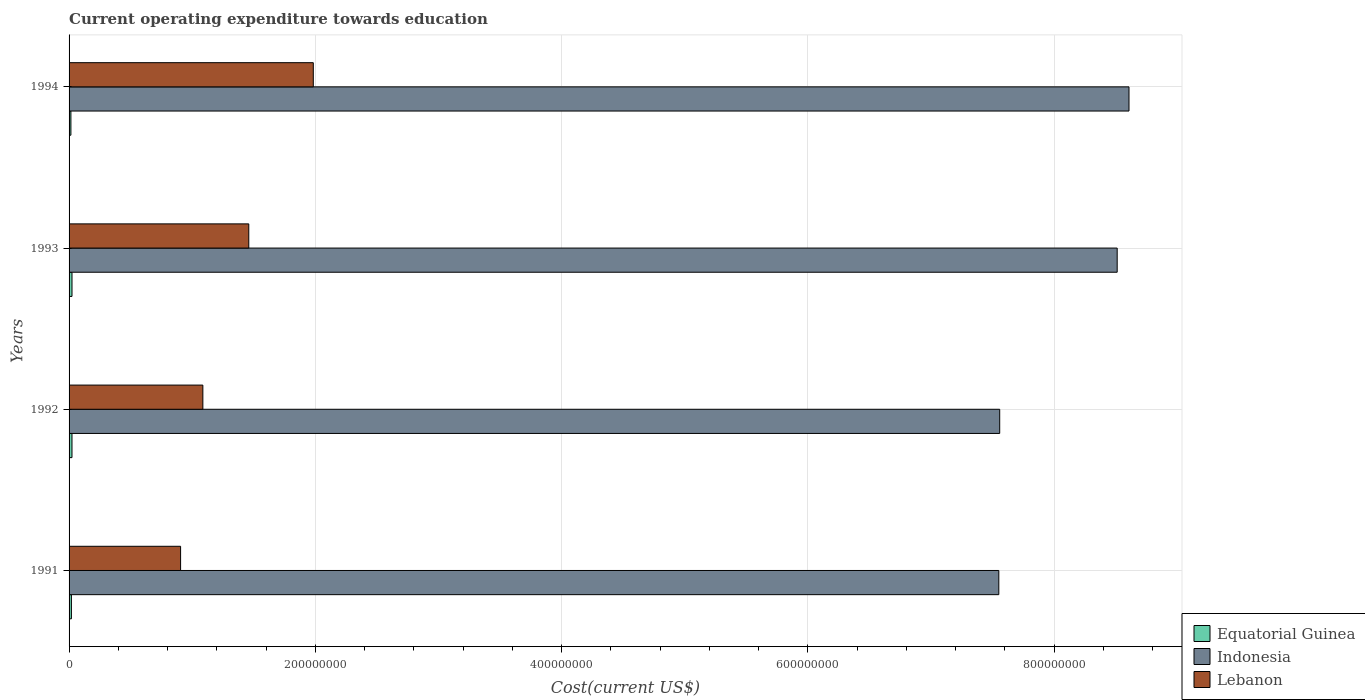How many different coloured bars are there?
Give a very brief answer. 3. How many groups of bars are there?
Keep it short and to the point. 4. Are the number of bars on each tick of the Y-axis equal?
Your answer should be very brief. Yes. How many bars are there on the 3rd tick from the top?
Make the answer very short. 3. What is the label of the 2nd group of bars from the top?
Ensure brevity in your answer.  1993. What is the expenditure towards education in Indonesia in 1992?
Your response must be concise. 7.56e+08. Across all years, what is the maximum expenditure towards education in Lebanon?
Keep it short and to the point. 1.98e+08. Across all years, what is the minimum expenditure towards education in Equatorial Guinea?
Provide a succinct answer. 1.50e+06. What is the total expenditure towards education in Indonesia in the graph?
Ensure brevity in your answer.  3.22e+09. What is the difference between the expenditure towards education in Equatorial Guinea in 1992 and that in 1993?
Your answer should be compact. -1.02e+04. What is the difference between the expenditure towards education in Equatorial Guinea in 1992 and the expenditure towards education in Indonesia in 1994?
Provide a succinct answer. -8.58e+08. What is the average expenditure towards education in Equatorial Guinea per year?
Provide a short and direct response. 2.03e+06. In the year 1992, what is the difference between the expenditure towards education in Indonesia and expenditure towards education in Lebanon?
Give a very brief answer. 6.47e+08. What is the ratio of the expenditure towards education in Indonesia in 1993 to that in 1994?
Provide a short and direct response. 0.99. Is the expenditure towards education in Indonesia in 1992 less than that in 1994?
Ensure brevity in your answer.  Yes. Is the difference between the expenditure towards education in Indonesia in 1992 and 1994 greater than the difference between the expenditure towards education in Lebanon in 1992 and 1994?
Your answer should be compact. No. What is the difference between the highest and the second highest expenditure towards education in Equatorial Guinea?
Offer a very short reply. 1.02e+04. What is the difference between the highest and the lowest expenditure towards education in Indonesia?
Your response must be concise. 1.06e+08. What does the 1st bar from the top in 1992 represents?
Keep it short and to the point. Lebanon. What does the 3rd bar from the bottom in 1993 represents?
Provide a succinct answer. Lebanon. Does the graph contain any zero values?
Your answer should be compact. No. Does the graph contain grids?
Your answer should be compact. Yes. Where does the legend appear in the graph?
Keep it short and to the point. Bottom right. What is the title of the graph?
Your answer should be compact. Current operating expenditure towards education. Does "Congo (Republic)" appear as one of the legend labels in the graph?
Provide a succinct answer. No. What is the label or title of the X-axis?
Offer a very short reply. Cost(current US$). What is the label or title of the Y-axis?
Ensure brevity in your answer.  Years. What is the Cost(current US$) of Equatorial Guinea in 1991?
Provide a short and direct response. 1.89e+06. What is the Cost(current US$) of Indonesia in 1991?
Ensure brevity in your answer.  7.55e+08. What is the Cost(current US$) in Lebanon in 1991?
Ensure brevity in your answer.  9.06e+07. What is the Cost(current US$) of Equatorial Guinea in 1992?
Give a very brief answer. 2.37e+06. What is the Cost(current US$) in Indonesia in 1992?
Ensure brevity in your answer.  7.56e+08. What is the Cost(current US$) in Lebanon in 1992?
Provide a short and direct response. 1.09e+08. What is the Cost(current US$) in Equatorial Guinea in 1993?
Provide a short and direct response. 2.38e+06. What is the Cost(current US$) in Indonesia in 1993?
Your response must be concise. 8.51e+08. What is the Cost(current US$) in Lebanon in 1993?
Make the answer very short. 1.46e+08. What is the Cost(current US$) of Equatorial Guinea in 1994?
Keep it short and to the point. 1.50e+06. What is the Cost(current US$) of Indonesia in 1994?
Offer a terse response. 8.61e+08. What is the Cost(current US$) in Lebanon in 1994?
Keep it short and to the point. 1.98e+08. Across all years, what is the maximum Cost(current US$) in Equatorial Guinea?
Your response must be concise. 2.38e+06. Across all years, what is the maximum Cost(current US$) of Indonesia?
Your answer should be very brief. 8.61e+08. Across all years, what is the maximum Cost(current US$) of Lebanon?
Your answer should be very brief. 1.98e+08. Across all years, what is the minimum Cost(current US$) of Equatorial Guinea?
Ensure brevity in your answer.  1.50e+06. Across all years, what is the minimum Cost(current US$) in Indonesia?
Keep it short and to the point. 7.55e+08. Across all years, what is the minimum Cost(current US$) in Lebanon?
Make the answer very short. 9.06e+07. What is the total Cost(current US$) in Equatorial Guinea in the graph?
Your response must be concise. 8.13e+06. What is the total Cost(current US$) in Indonesia in the graph?
Provide a short and direct response. 3.22e+09. What is the total Cost(current US$) of Lebanon in the graph?
Your answer should be compact. 5.43e+08. What is the difference between the Cost(current US$) of Equatorial Guinea in 1991 and that in 1992?
Make the answer very short. -4.75e+05. What is the difference between the Cost(current US$) of Indonesia in 1991 and that in 1992?
Your answer should be very brief. -7.18e+05. What is the difference between the Cost(current US$) of Lebanon in 1991 and that in 1992?
Provide a short and direct response. -1.81e+07. What is the difference between the Cost(current US$) in Equatorial Guinea in 1991 and that in 1993?
Offer a terse response. -4.86e+05. What is the difference between the Cost(current US$) in Indonesia in 1991 and that in 1993?
Offer a very short reply. -9.61e+07. What is the difference between the Cost(current US$) in Lebanon in 1991 and that in 1993?
Offer a terse response. -5.54e+07. What is the difference between the Cost(current US$) of Equatorial Guinea in 1991 and that in 1994?
Your answer should be compact. 3.95e+05. What is the difference between the Cost(current US$) of Indonesia in 1991 and that in 1994?
Provide a short and direct response. -1.06e+08. What is the difference between the Cost(current US$) of Lebanon in 1991 and that in 1994?
Provide a succinct answer. -1.08e+08. What is the difference between the Cost(current US$) of Equatorial Guinea in 1992 and that in 1993?
Provide a short and direct response. -1.02e+04. What is the difference between the Cost(current US$) of Indonesia in 1992 and that in 1993?
Offer a very short reply. -9.54e+07. What is the difference between the Cost(current US$) in Lebanon in 1992 and that in 1993?
Ensure brevity in your answer.  -3.73e+07. What is the difference between the Cost(current US$) of Equatorial Guinea in 1992 and that in 1994?
Ensure brevity in your answer.  8.70e+05. What is the difference between the Cost(current US$) in Indonesia in 1992 and that in 1994?
Provide a short and direct response. -1.05e+08. What is the difference between the Cost(current US$) in Lebanon in 1992 and that in 1994?
Your answer should be compact. -8.97e+07. What is the difference between the Cost(current US$) in Equatorial Guinea in 1993 and that in 1994?
Make the answer very short. 8.81e+05. What is the difference between the Cost(current US$) of Indonesia in 1993 and that in 1994?
Make the answer very short. -9.59e+06. What is the difference between the Cost(current US$) of Lebanon in 1993 and that in 1994?
Offer a terse response. -5.24e+07. What is the difference between the Cost(current US$) in Equatorial Guinea in 1991 and the Cost(current US$) in Indonesia in 1992?
Keep it short and to the point. -7.54e+08. What is the difference between the Cost(current US$) of Equatorial Guinea in 1991 and the Cost(current US$) of Lebanon in 1992?
Your response must be concise. -1.07e+08. What is the difference between the Cost(current US$) in Indonesia in 1991 and the Cost(current US$) in Lebanon in 1992?
Offer a terse response. 6.46e+08. What is the difference between the Cost(current US$) in Equatorial Guinea in 1991 and the Cost(current US$) in Indonesia in 1993?
Your response must be concise. -8.49e+08. What is the difference between the Cost(current US$) in Equatorial Guinea in 1991 and the Cost(current US$) in Lebanon in 1993?
Your answer should be compact. -1.44e+08. What is the difference between the Cost(current US$) of Indonesia in 1991 and the Cost(current US$) of Lebanon in 1993?
Your response must be concise. 6.09e+08. What is the difference between the Cost(current US$) in Equatorial Guinea in 1991 and the Cost(current US$) in Indonesia in 1994?
Offer a very short reply. -8.59e+08. What is the difference between the Cost(current US$) in Equatorial Guinea in 1991 and the Cost(current US$) in Lebanon in 1994?
Offer a very short reply. -1.96e+08. What is the difference between the Cost(current US$) in Indonesia in 1991 and the Cost(current US$) in Lebanon in 1994?
Your answer should be compact. 5.57e+08. What is the difference between the Cost(current US$) of Equatorial Guinea in 1992 and the Cost(current US$) of Indonesia in 1993?
Keep it short and to the point. -8.49e+08. What is the difference between the Cost(current US$) of Equatorial Guinea in 1992 and the Cost(current US$) of Lebanon in 1993?
Your answer should be compact. -1.44e+08. What is the difference between the Cost(current US$) in Indonesia in 1992 and the Cost(current US$) in Lebanon in 1993?
Your response must be concise. 6.10e+08. What is the difference between the Cost(current US$) in Equatorial Guinea in 1992 and the Cost(current US$) in Indonesia in 1994?
Give a very brief answer. -8.58e+08. What is the difference between the Cost(current US$) of Equatorial Guinea in 1992 and the Cost(current US$) of Lebanon in 1994?
Provide a succinct answer. -1.96e+08. What is the difference between the Cost(current US$) of Indonesia in 1992 and the Cost(current US$) of Lebanon in 1994?
Offer a terse response. 5.57e+08. What is the difference between the Cost(current US$) in Equatorial Guinea in 1993 and the Cost(current US$) in Indonesia in 1994?
Your answer should be very brief. -8.58e+08. What is the difference between the Cost(current US$) in Equatorial Guinea in 1993 and the Cost(current US$) in Lebanon in 1994?
Ensure brevity in your answer.  -1.96e+08. What is the difference between the Cost(current US$) of Indonesia in 1993 and the Cost(current US$) of Lebanon in 1994?
Offer a terse response. 6.53e+08. What is the average Cost(current US$) of Equatorial Guinea per year?
Your response must be concise. 2.03e+06. What is the average Cost(current US$) in Indonesia per year?
Make the answer very short. 8.06e+08. What is the average Cost(current US$) of Lebanon per year?
Your response must be concise. 1.36e+08. In the year 1991, what is the difference between the Cost(current US$) in Equatorial Guinea and Cost(current US$) in Indonesia?
Make the answer very short. -7.53e+08. In the year 1991, what is the difference between the Cost(current US$) in Equatorial Guinea and Cost(current US$) in Lebanon?
Keep it short and to the point. -8.87e+07. In the year 1991, what is the difference between the Cost(current US$) in Indonesia and Cost(current US$) in Lebanon?
Your response must be concise. 6.64e+08. In the year 1992, what is the difference between the Cost(current US$) of Equatorial Guinea and Cost(current US$) of Indonesia?
Ensure brevity in your answer.  -7.53e+08. In the year 1992, what is the difference between the Cost(current US$) of Equatorial Guinea and Cost(current US$) of Lebanon?
Ensure brevity in your answer.  -1.06e+08. In the year 1992, what is the difference between the Cost(current US$) in Indonesia and Cost(current US$) in Lebanon?
Your response must be concise. 6.47e+08. In the year 1993, what is the difference between the Cost(current US$) of Equatorial Guinea and Cost(current US$) of Indonesia?
Offer a terse response. -8.49e+08. In the year 1993, what is the difference between the Cost(current US$) of Equatorial Guinea and Cost(current US$) of Lebanon?
Your answer should be very brief. -1.44e+08. In the year 1993, what is the difference between the Cost(current US$) of Indonesia and Cost(current US$) of Lebanon?
Offer a terse response. 7.05e+08. In the year 1994, what is the difference between the Cost(current US$) of Equatorial Guinea and Cost(current US$) of Indonesia?
Your answer should be compact. -8.59e+08. In the year 1994, what is the difference between the Cost(current US$) of Equatorial Guinea and Cost(current US$) of Lebanon?
Keep it short and to the point. -1.97e+08. In the year 1994, what is the difference between the Cost(current US$) of Indonesia and Cost(current US$) of Lebanon?
Provide a succinct answer. 6.62e+08. What is the ratio of the Cost(current US$) in Equatorial Guinea in 1991 to that in 1992?
Your response must be concise. 0.8. What is the ratio of the Cost(current US$) in Lebanon in 1991 to that in 1992?
Your response must be concise. 0.83. What is the ratio of the Cost(current US$) of Equatorial Guinea in 1991 to that in 1993?
Your answer should be compact. 0.8. What is the ratio of the Cost(current US$) in Indonesia in 1991 to that in 1993?
Your response must be concise. 0.89. What is the ratio of the Cost(current US$) of Lebanon in 1991 to that in 1993?
Your answer should be compact. 0.62. What is the ratio of the Cost(current US$) of Equatorial Guinea in 1991 to that in 1994?
Keep it short and to the point. 1.26. What is the ratio of the Cost(current US$) of Indonesia in 1991 to that in 1994?
Ensure brevity in your answer.  0.88. What is the ratio of the Cost(current US$) in Lebanon in 1991 to that in 1994?
Provide a succinct answer. 0.46. What is the ratio of the Cost(current US$) in Equatorial Guinea in 1992 to that in 1993?
Your response must be concise. 1. What is the ratio of the Cost(current US$) of Indonesia in 1992 to that in 1993?
Give a very brief answer. 0.89. What is the ratio of the Cost(current US$) of Lebanon in 1992 to that in 1993?
Provide a short and direct response. 0.74. What is the ratio of the Cost(current US$) in Equatorial Guinea in 1992 to that in 1994?
Make the answer very short. 1.58. What is the ratio of the Cost(current US$) in Indonesia in 1992 to that in 1994?
Your response must be concise. 0.88. What is the ratio of the Cost(current US$) in Lebanon in 1992 to that in 1994?
Your answer should be very brief. 0.55. What is the ratio of the Cost(current US$) in Equatorial Guinea in 1993 to that in 1994?
Ensure brevity in your answer.  1.59. What is the ratio of the Cost(current US$) of Indonesia in 1993 to that in 1994?
Provide a succinct answer. 0.99. What is the ratio of the Cost(current US$) in Lebanon in 1993 to that in 1994?
Your answer should be compact. 0.74. What is the difference between the highest and the second highest Cost(current US$) in Equatorial Guinea?
Provide a short and direct response. 1.02e+04. What is the difference between the highest and the second highest Cost(current US$) in Indonesia?
Keep it short and to the point. 9.59e+06. What is the difference between the highest and the second highest Cost(current US$) of Lebanon?
Offer a terse response. 5.24e+07. What is the difference between the highest and the lowest Cost(current US$) in Equatorial Guinea?
Give a very brief answer. 8.81e+05. What is the difference between the highest and the lowest Cost(current US$) in Indonesia?
Your response must be concise. 1.06e+08. What is the difference between the highest and the lowest Cost(current US$) in Lebanon?
Provide a succinct answer. 1.08e+08. 